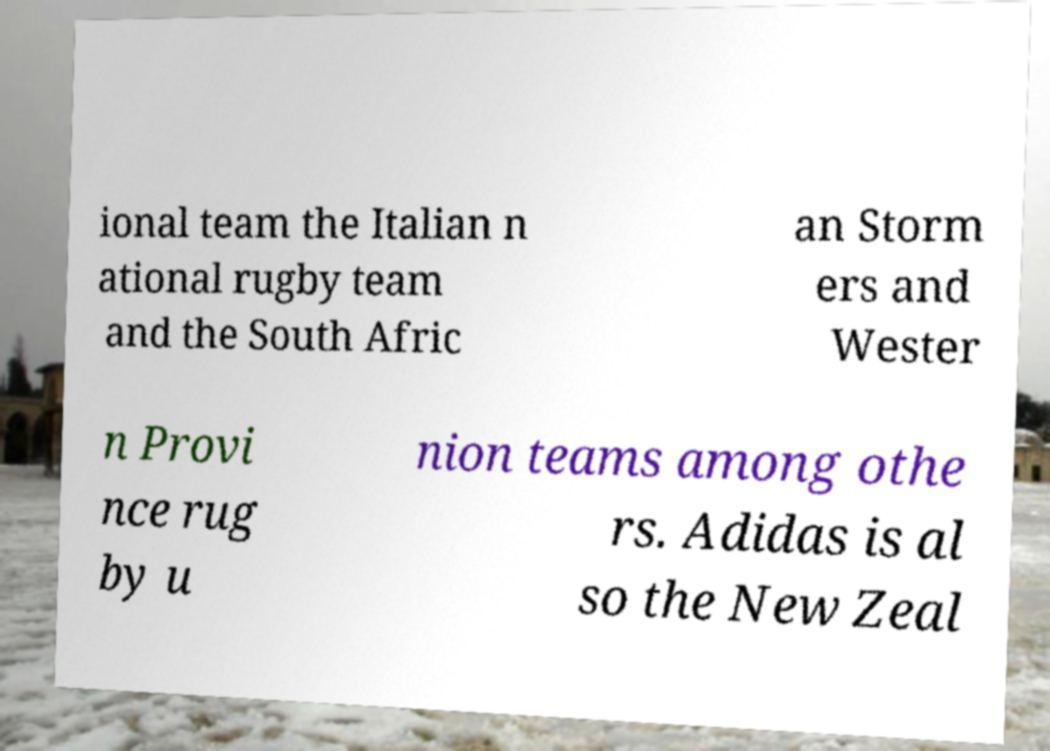Could you extract and type out the text from this image? ional team the Italian n ational rugby team and the South Afric an Storm ers and Wester n Provi nce rug by u nion teams among othe rs. Adidas is al so the New Zeal 